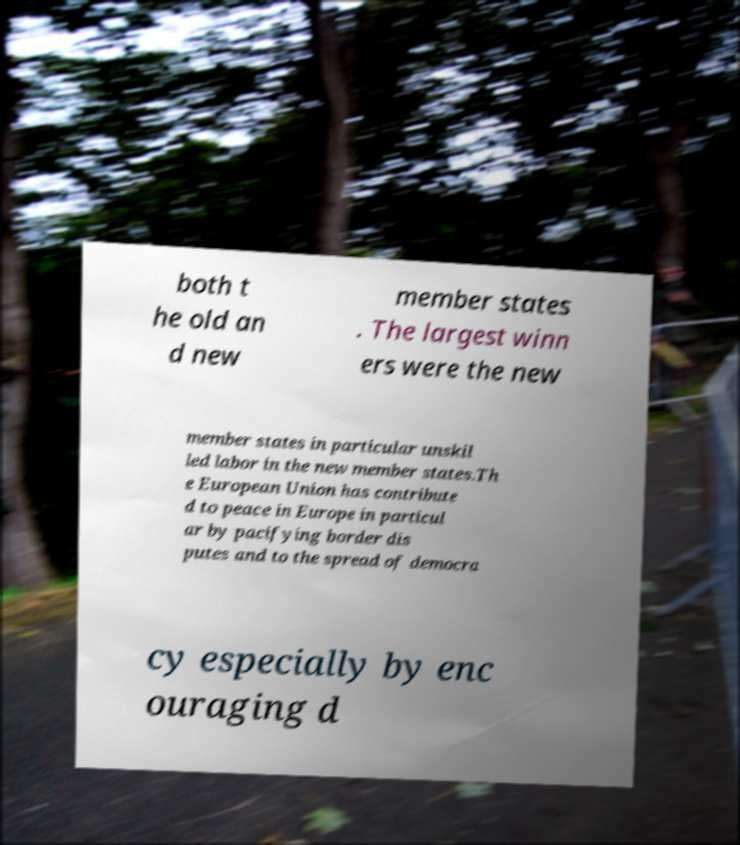I need the written content from this picture converted into text. Can you do that? both t he old an d new member states . The largest winn ers were the new member states in particular unskil led labor in the new member states.Th e European Union has contribute d to peace in Europe in particul ar by pacifying border dis putes and to the spread of democra cy especially by enc ouraging d 